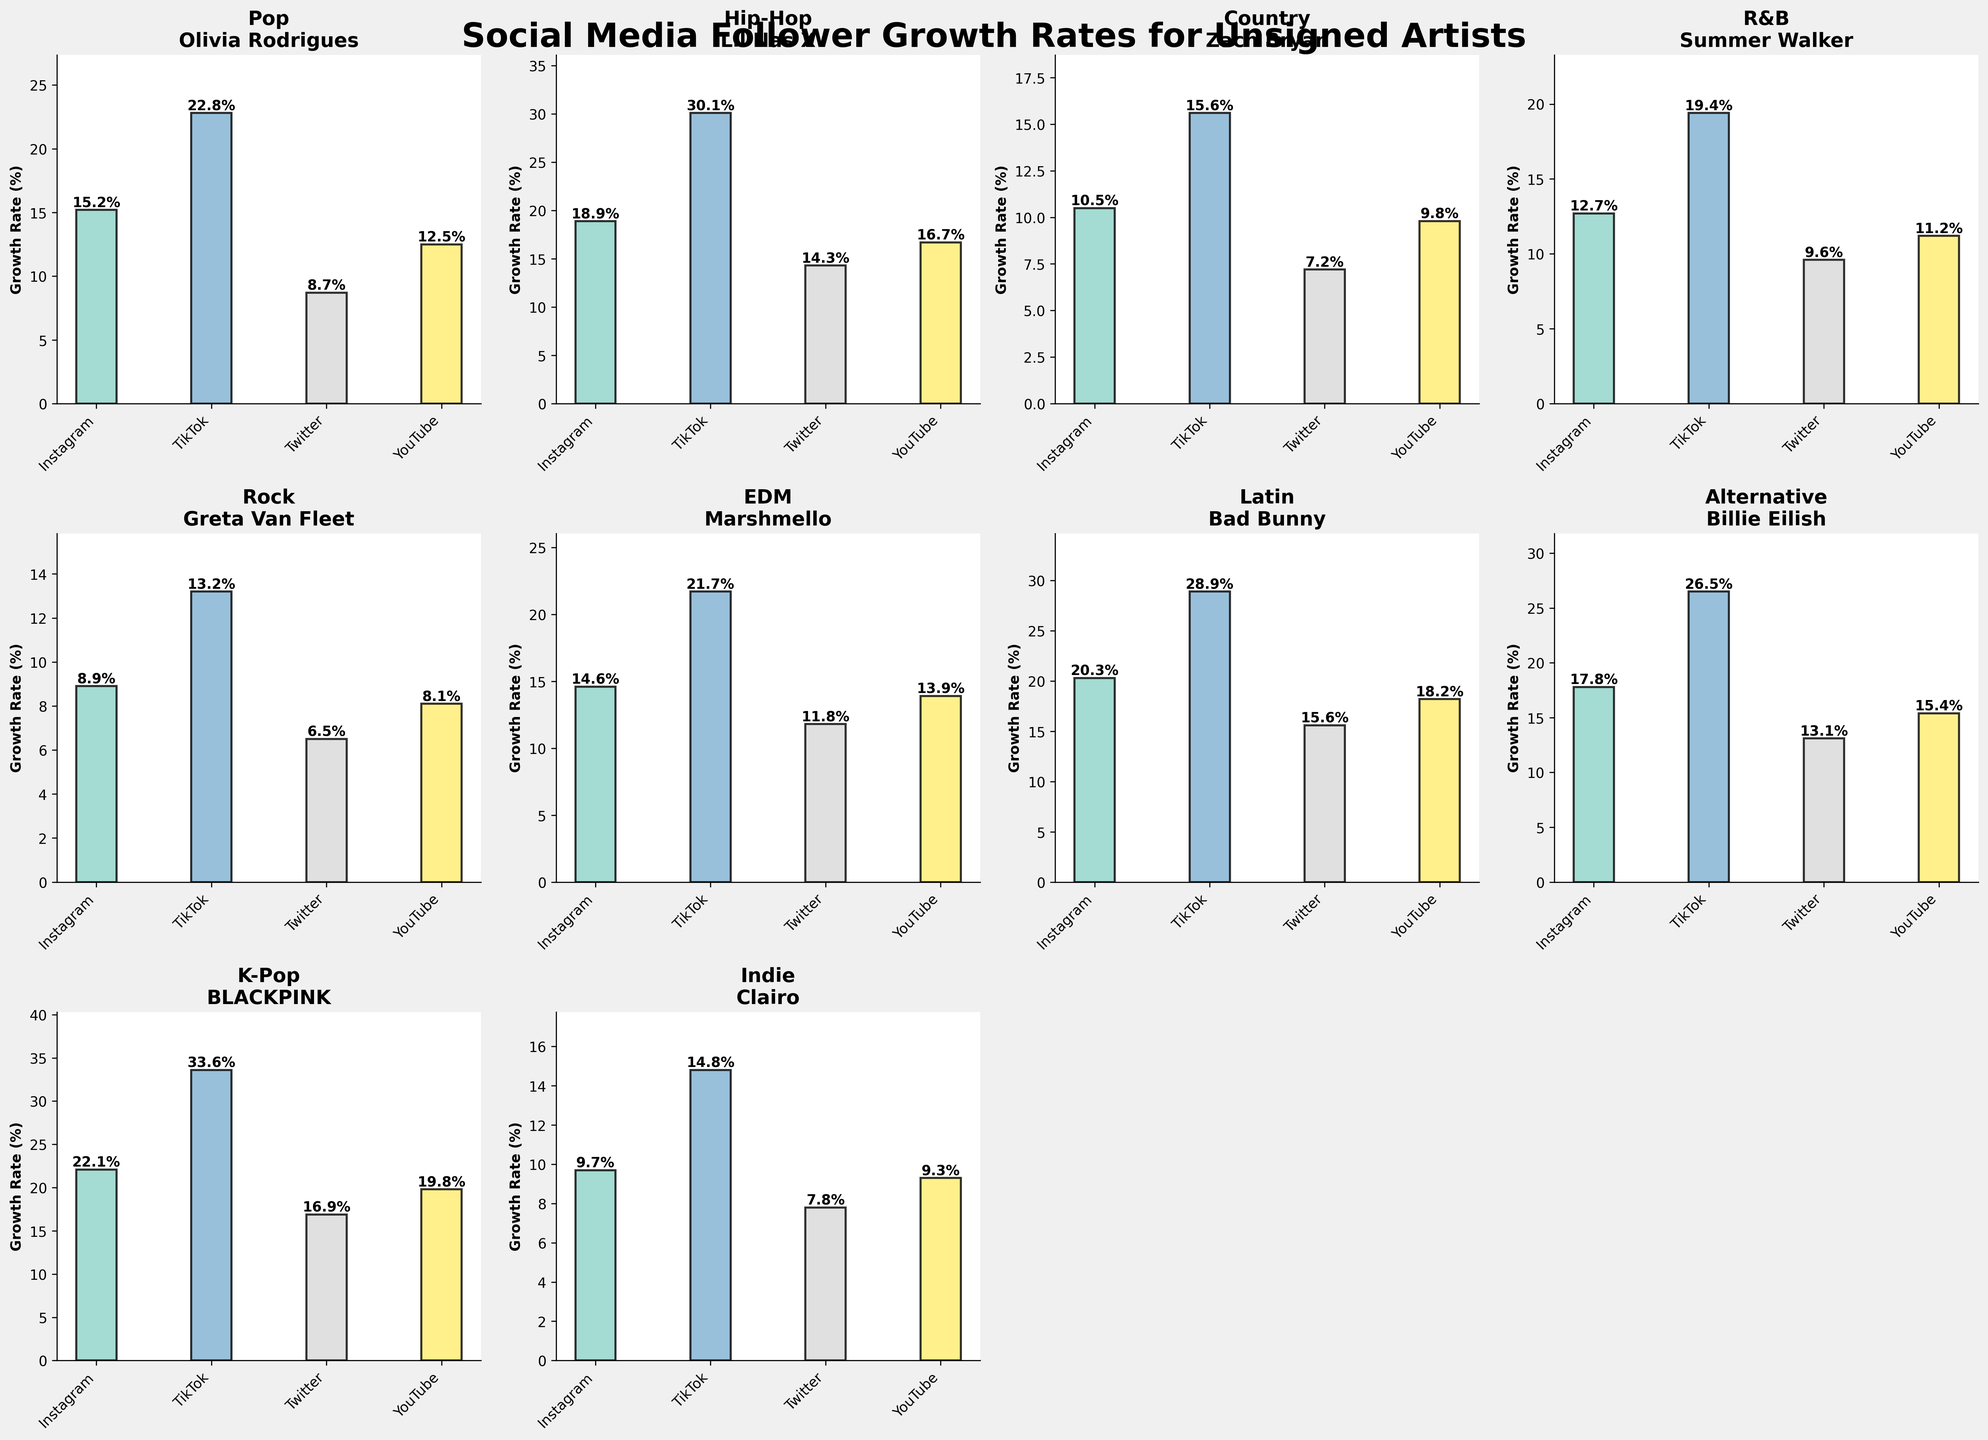How many genres are represented in the figure? Count the number of unique genres displayed in the titles of the subplots.
Answer: 10 Which genre has the artist with the highest Instagram growth rate? Look at the Instagram bar heights in each subplot and identify the tallest one.
Answer: K-Pop What is the total Twitter growth rate percentage for Hip-Hop and R&B combined? Sum the Twitter growth rates for Hip-Hop and R&B (14.3 + 9.6).
Answer: 23.9% Which platform has the greatest growth rate for Alternative genre artist Billie Eilish? Look at the bar heights in the Alternative subplot and identify the tallest one.
Answer: TikTok Which artist has a higher YouTube growth rate: Zach Bryan (Country) or Greta Van Fleet (Rock)? Compare the YouTube growth bars in the Rock and Country subplots.
Answer: Zach Bryan What is the average Instagram growth rate for the artists from the genres Pop, Rock, and EDM? Sum the Instagram growth rates for Pop, Rock, and EDM, and divide by the number of genres (15.2 + 8.9 + 14.6) / 3.
Answer: 12.9% Does any artist have the highest growth rate across all four social media platforms? Check each subplot to see if any artist has the tallest bar in every platform category.
Answer: No Which genre has the artist with the highest total social media growth rate across all platforms? Sum the growth rates for each genre's artist and compare; K-Pop has the highest total (22.1 + 33.6 + 16.9 + 19.8).
Answer: K-Pop What is the difference in TikTok growth rates between Olivia Rodrigues (Pop) and Lil Nas X (Hip-Hop)? Subtract Olivia Rodrigues' TikTok rate from Lil Nas X's TikTok rate (30.1 - 22.8).
Answer: 7.3% What is the combined growth rate for TikTok and YouTube for Blackpink (K-Pop)? Sum the TikTok and YouTube growth rates for Blackpink (33.6 + 19.8).
Answer: 53.4% 